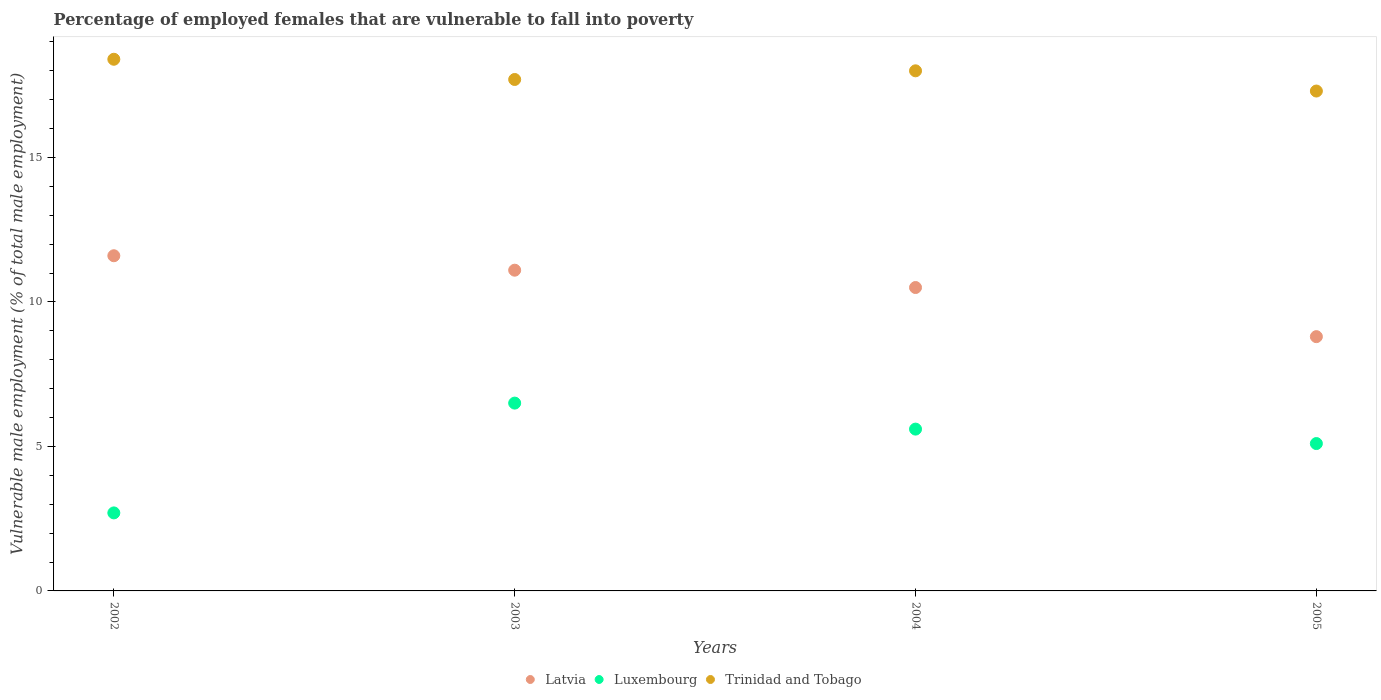How many different coloured dotlines are there?
Give a very brief answer. 3. Is the number of dotlines equal to the number of legend labels?
Ensure brevity in your answer.  Yes. What is the percentage of employed females who are vulnerable to fall into poverty in Latvia in 2003?
Make the answer very short. 11.1. Across all years, what is the maximum percentage of employed females who are vulnerable to fall into poverty in Latvia?
Your answer should be compact. 11.6. Across all years, what is the minimum percentage of employed females who are vulnerable to fall into poverty in Luxembourg?
Your answer should be very brief. 2.7. In which year was the percentage of employed females who are vulnerable to fall into poverty in Trinidad and Tobago maximum?
Make the answer very short. 2002. In which year was the percentage of employed females who are vulnerable to fall into poverty in Latvia minimum?
Keep it short and to the point. 2005. What is the total percentage of employed females who are vulnerable to fall into poverty in Luxembourg in the graph?
Keep it short and to the point. 19.9. What is the difference between the percentage of employed females who are vulnerable to fall into poverty in Latvia in 2003 and that in 2004?
Your response must be concise. 0.6. What is the difference between the percentage of employed females who are vulnerable to fall into poverty in Latvia in 2003 and the percentage of employed females who are vulnerable to fall into poverty in Trinidad and Tobago in 2005?
Give a very brief answer. -6.2. What is the average percentage of employed females who are vulnerable to fall into poverty in Latvia per year?
Your answer should be very brief. 10.5. In the year 2002, what is the difference between the percentage of employed females who are vulnerable to fall into poverty in Luxembourg and percentage of employed females who are vulnerable to fall into poverty in Latvia?
Offer a very short reply. -8.9. What is the ratio of the percentage of employed females who are vulnerable to fall into poverty in Trinidad and Tobago in 2004 to that in 2005?
Keep it short and to the point. 1.04. Is the percentage of employed females who are vulnerable to fall into poverty in Trinidad and Tobago in 2004 less than that in 2005?
Make the answer very short. No. Is the difference between the percentage of employed females who are vulnerable to fall into poverty in Luxembourg in 2003 and 2004 greater than the difference between the percentage of employed females who are vulnerable to fall into poverty in Latvia in 2003 and 2004?
Ensure brevity in your answer.  Yes. What is the difference between the highest and the second highest percentage of employed females who are vulnerable to fall into poverty in Luxembourg?
Ensure brevity in your answer.  0.9. What is the difference between the highest and the lowest percentage of employed females who are vulnerable to fall into poverty in Luxembourg?
Offer a terse response. 3.8. In how many years, is the percentage of employed females who are vulnerable to fall into poverty in Trinidad and Tobago greater than the average percentage of employed females who are vulnerable to fall into poverty in Trinidad and Tobago taken over all years?
Make the answer very short. 2. Is the sum of the percentage of employed females who are vulnerable to fall into poverty in Trinidad and Tobago in 2002 and 2005 greater than the maximum percentage of employed females who are vulnerable to fall into poverty in Luxembourg across all years?
Provide a short and direct response. Yes. Is it the case that in every year, the sum of the percentage of employed females who are vulnerable to fall into poverty in Luxembourg and percentage of employed females who are vulnerable to fall into poverty in Latvia  is greater than the percentage of employed females who are vulnerable to fall into poverty in Trinidad and Tobago?
Your answer should be compact. No. Is the percentage of employed females who are vulnerable to fall into poverty in Luxembourg strictly greater than the percentage of employed females who are vulnerable to fall into poverty in Latvia over the years?
Your response must be concise. No. Is the percentage of employed females who are vulnerable to fall into poverty in Luxembourg strictly less than the percentage of employed females who are vulnerable to fall into poverty in Latvia over the years?
Provide a short and direct response. Yes. How many dotlines are there?
Make the answer very short. 3. How many years are there in the graph?
Provide a short and direct response. 4. What is the difference between two consecutive major ticks on the Y-axis?
Provide a short and direct response. 5. Are the values on the major ticks of Y-axis written in scientific E-notation?
Give a very brief answer. No. Does the graph contain any zero values?
Your answer should be compact. No. How many legend labels are there?
Offer a terse response. 3. What is the title of the graph?
Your answer should be compact. Percentage of employed females that are vulnerable to fall into poverty. What is the label or title of the Y-axis?
Keep it short and to the point. Vulnerable male employment (% of total male employment). What is the Vulnerable male employment (% of total male employment) of Latvia in 2002?
Your answer should be very brief. 11.6. What is the Vulnerable male employment (% of total male employment) in Luxembourg in 2002?
Keep it short and to the point. 2.7. What is the Vulnerable male employment (% of total male employment) of Trinidad and Tobago in 2002?
Provide a succinct answer. 18.4. What is the Vulnerable male employment (% of total male employment) of Latvia in 2003?
Your answer should be very brief. 11.1. What is the Vulnerable male employment (% of total male employment) in Trinidad and Tobago in 2003?
Your answer should be compact. 17.7. What is the Vulnerable male employment (% of total male employment) of Luxembourg in 2004?
Make the answer very short. 5.6. What is the Vulnerable male employment (% of total male employment) in Latvia in 2005?
Provide a short and direct response. 8.8. What is the Vulnerable male employment (% of total male employment) of Luxembourg in 2005?
Ensure brevity in your answer.  5.1. What is the Vulnerable male employment (% of total male employment) in Trinidad and Tobago in 2005?
Make the answer very short. 17.3. Across all years, what is the maximum Vulnerable male employment (% of total male employment) of Latvia?
Make the answer very short. 11.6. Across all years, what is the maximum Vulnerable male employment (% of total male employment) of Trinidad and Tobago?
Make the answer very short. 18.4. Across all years, what is the minimum Vulnerable male employment (% of total male employment) of Latvia?
Keep it short and to the point. 8.8. Across all years, what is the minimum Vulnerable male employment (% of total male employment) in Luxembourg?
Ensure brevity in your answer.  2.7. Across all years, what is the minimum Vulnerable male employment (% of total male employment) in Trinidad and Tobago?
Your answer should be very brief. 17.3. What is the total Vulnerable male employment (% of total male employment) in Trinidad and Tobago in the graph?
Keep it short and to the point. 71.4. What is the difference between the Vulnerable male employment (% of total male employment) in Luxembourg in 2002 and that in 2003?
Your response must be concise. -3.8. What is the difference between the Vulnerable male employment (% of total male employment) of Latvia in 2002 and that in 2004?
Your answer should be very brief. 1.1. What is the difference between the Vulnerable male employment (% of total male employment) in Luxembourg in 2002 and that in 2004?
Your answer should be very brief. -2.9. What is the difference between the Vulnerable male employment (% of total male employment) in Trinidad and Tobago in 2002 and that in 2004?
Ensure brevity in your answer.  0.4. What is the difference between the Vulnerable male employment (% of total male employment) in Latvia in 2002 and that in 2005?
Provide a succinct answer. 2.8. What is the difference between the Vulnerable male employment (% of total male employment) of Trinidad and Tobago in 2002 and that in 2005?
Keep it short and to the point. 1.1. What is the difference between the Vulnerable male employment (% of total male employment) of Luxembourg in 2003 and that in 2004?
Make the answer very short. 0.9. What is the difference between the Vulnerable male employment (% of total male employment) of Luxembourg in 2003 and that in 2005?
Your answer should be very brief. 1.4. What is the difference between the Vulnerable male employment (% of total male employment) in Trinidad and Tobago in 2003 and that in 2005?
Ensure brevity in your answer.  0.4. What is the difference between the Vulnerable male employment (% of total male employment) in Latvia in 2004 and that in 2005?
Offer a terse response. 1.7. What is the difference between the Vulnerable male employment (% of total male employment) of Luxembourg in 2004 and that in 2005?
Keep it short and to the point. 0.5. What is the difference between the Vulnerable male employment (% of total male employment) in Trinidad and Tobago in 2004 and that in 2005?
Ensure brevity in your answer.  0.7. What is the difference between the Vulnerable male employment (% of total male employment) in Latvia in 2002 and the Vulnerable male employment (% of total male employment) in Luxembourg in 2003?
Offer a very short reply. 5.1. What is the difference between the Vulnerable male employment (% of total male employment) in Luxembourg in 2002 and the Vulnerable male employment (% of total male employment) in Trinidad and Tobago in 2003?
Offer a terse response. -15. What is the difference between the Vulnerable male employment (% of total male employment) of Latvia in 2002 and the Vulnerable male employment (% of total male employment) of Luxembourg in 2004?
Your answer should be very brief. 6. What is the difference between the Vulnerable male employment (% of total male employment) of Latvia in 2002 and the Vulnerable male employment (% of total male employment) of Trinidad and Tobago in 2004?
Make the answer very short. -6.4. What is the difference between the Vulnerable male employment (% of total male employment) in Luxembourg in 2002 and the Vulnerable male employment (% of total male employment) in Trinidad and Tobago in 2004?
Provide a short and direct response. -15.3. What is the difference between the Vulnerable male employment (% of total male employment) in Latvia in 2002 and the Vulnerable male employment (% of total male employment) in Luxembourg in 2005?
Keep it short and to the point. 6.5. What is the difference between the Vulnerable male employment (% of total male employment) of Latvia in 2002 and the Vulnerable male employment (% of total male employment) of Trinidad and Tobago in 2005?
Provide a short and direct response. -5.7. What is the difference between the Vulnerable male employment (% of total male employment) of Luxembourg in 2002 and the Vulnerable male employment (% of total male employment) of Trinidad and Tobago in 2005?
Make the answer very short. -14.6. What is the difference between the Vulnerable male employment (% of total male employment) in Latvia in 2003 and the Vulnerable male employment (% of total male employment) in Luxembourg in 2004?
Ensure brevity in your answer.  5.5. What is the difference between the Vulnerable male employment (% of total male employment) of Luxembourg in 2003 and the Vulnerable male employment (% of total male employment) of Trinidad and Tobago in 2004?
Give a very brief answer. -11.5. What is the difference between the Vulnerable male employment (% of total male employment) of Latvia in 2003 and the Vulnerable male employment (% of total male employment) of Trinidad and Tobago in 2005?
Keep it short and to the point. -6.2. What is the difference between the Vulnerable male employment (% of total male employment) in Luxembourg in 2003 and the Vulnerable male employment (% of total male employment) in Trinidad and Tobago in 2005?
Your response must be concise. -10.8. What is the difference between the Vulnerable male employment (% of total male employment) in Latvia in 2004 and the Vulnerable male employment (% of total male employment) in Luxembourg in 2005?
Offer a very short reply. 5.4. What is the average Vulnerable male employment (% of total male employment) in Latvia per year?
Your answer should be compact. 10.5. What is the average Vulnerable male employment (% of total male employment) in Luxembourg per year?
Keep it short and to the point. 4.97. What is the average Vulnerable male employment (% of total male employment) in Trinidad and Tobago per year?
Your response must be concise. 17.85. In the year 2002, what is the difference between the Vulnerable male employment (% of total male employment) of Latvia and Vulnerable male employment (% of total male employment) of Luxembourg?
Give a very brief answer. 8.9. In the year 2002, what is the difference between the Vulnerable male employment (% of total male employment) of Latvia and Vulnerable male employment (% of total male employment) of Trinidad and Tobago?
Offer a terse response. -6.8. In the year 2002, what is the difference between the Vulnerable male employment (% of total male employment) in Luxembourg and Vulnerable male employment (% of total male employment) in Trinidad and Tobago?
Offer a terse response. -15.7. In the year 2003, what is the difference between the Vulnerable male employment (% of total male employment) in Latvia and Vulnerable male employment (% of total male employment) in Luxembourg?
Ensure brevity in your answer.  4.6. In the year 2003, what is the difference between the Vulnerable male employment (% of total male employment) of Latvia and Vulnerable male employment (% of total male employment) of Trinidad and Tobago?
Offer a very short reply. -6.6. In the year 2003, what is the difference between the Vulnerable male employment (% of total male employment) of Luxembourg and Vulnerable male employment (% of total male employment) of Trinidad and Tobago?
Provide a short and direct response. -11.2. In the year 2004, what is the difference between the Vulnerable male employment (% of total male employment) of Latvia and Vulnerable male employment (% of total male employment) of Trinidad and Tobago?
Make the answer very short. -7.5. In the year 2004, what is the difference between the Vulnerable male employment (% of total male employment) of Luxembourg and Vulnerable male employment (% of total male employment) of Trinidad and Tobago?
Your answer should be compact. -12.4. In the year 2005, what is the difference between the Vulnerable male employment (% of total male employment) of Latvia and Vulnerable male employment (% of total male employment) of Luxembourg?
Keep it short and to the point. 3.7. In the year 2005, what is the difference between the Vulnerable male employment (% of total male employment) of Latvia and Vulnerable male employment (% of total male employment) of Trinidad and Tobago?
Provide a succinct answer. -8.5. What is the ratio of the Vulnerable male employment (% of total male employment) in Latvia in 2002 to that in 2003?
Offer a terse response. 1.04. What is the ratio of the Vulnerable male employment (% of total male employment) of Luxembourg in 2002 to that in 2003?
Provide a short and direct response. 0.42. What is the ratio of the Vulnerable male employment (% of total male employment) of Trinidad and Tobago in 2002 to that in 2003?
Give a very brief answer. 1.04. What is the ratio of the Vulnerable male employment (% of total male employment) in Latvia in 2002 to that in 2004?
Keep it short and to the point. 1.1. What is the ratio of the Vulnerable male employment (% of total male employment) of Luxembourg in 2002 to that in 2004?
Keep it short and to the point. 0.48. What is the ratio of the Vulnerable male employment (% of total male employment) in Trinidad and Tobago in 2002 to that in 2004?
Ensure brevity in your answer.  1.02. What is the ratio of the Vulnerable male employment (% of total male employment) of Latvia in 2002 to that in 2005?
Make the answer very short. 1.32. What is the ratio of the Vulnerable male employment (% of total male employment) in Luxembourg in 2002 to that in 2005?
Provide a succinct answer. 0.53. What is the ratio of the Vulnerable male employment (% of total male employment) in Trinidad and Tobago in 2002 to that in 2005?
Offer a very short reply. 1.06. What is the ratio of the Vulnerable male employment (% of total male employment) of Latvia in 2003 to that in 2004?
Your answer should be very brief. 1.06. What is the ratio of the Vulnerable male employment (% of total male employment) in Luxembourg in 2003 to that in 2004?
Offer a very short reply. 1.16. What is the ratio of the Vulnerable male employment (% of total male employment) of Trinidad and Tobago in 2003 to that in 2004?
Offer a terse response. 0.98. What is the ratio of the Vulnerable male employment (% of total male employment) in Latvia in 2003 to that in 2005?
Give a very brief answer. 1.26. What is the ratio of the Vulnerable male employment (% of total male employment) in Luxembourg in 2003 to that in 2005?
Provide a succinct answer. 1.27. What is the ratio of the Vulnerable male employment (% of total male employment) of Trinidad and Tobago in 2003 to that in 2005?
Provide a succinct answer. 1.02. What is the ratio of the Vulnerable male employment (% of total male employment) of Latvia in 2004 to that in 2005?
Keep it short and to the point. 1.19. What is the ratio of the Vulnerable male employment (% of total male employment) in Luxembourg in 2004 to that in 2005?
Keep it short and to the point. 1.1. What is the ratio of the Vulnerable male employment (% of total male employment) in Trinidad and Tobago in 2004 to that in 2005?
Give a very brief answer. 1.04. What is the difference between the highest and the second highest Vulnerable male employment (% of total male employment) of Latvia?
Your response must be concise. 0.5. What is the difference between the highest and the second highest Vulnerable male employment (% of total male employment) of Luxembourg?
Your answer should be compact. 0.9. What is the difference between the highest and the lowest Vulnerable male employment (% of total male employment) of Latvia?
Provide a short and direct response. 2.8. What is the difference between the highest and the lowest Vulnerable male employment (% of total male employment) in Luxembourg?
Ensure brevity in your answer.  3.8. What is the difference between the highest and the lowest Vulnerable male employment (% of total male employment) in Trinidad and Tobago?
Provide a short and direct response. 1.1. 